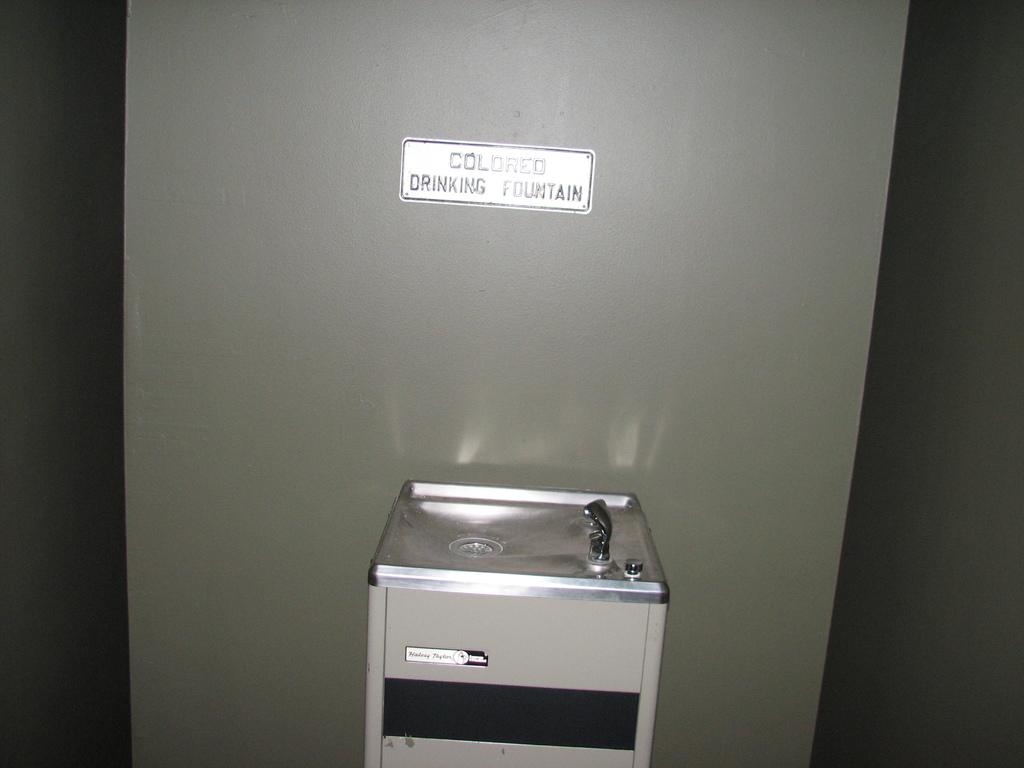Who is this drinking fountain for?
Provide a short and direct response. Colored. Is this a drinking fountain?
Keep it short and to the point. Yes. 